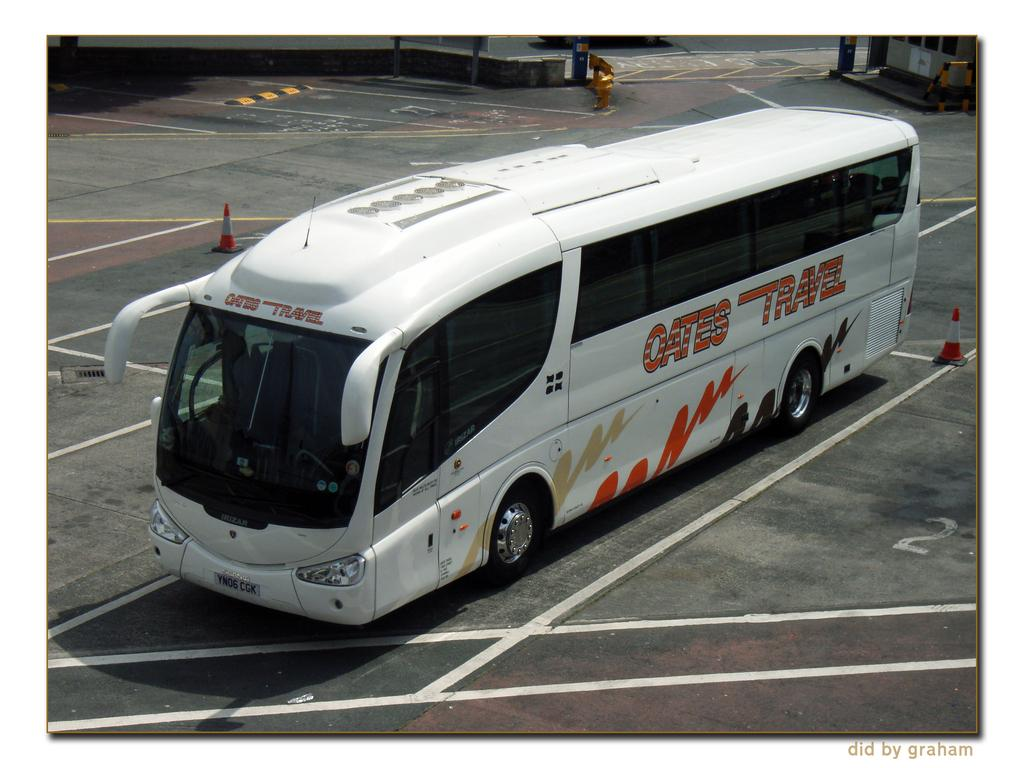What is the main subject of the image? There is a bus in the image. Where is the bus located? The bus is parked in a parking lot. What can be seen in the background of the image? There is a building, two cones, and a metal barricade in the background of the image. What type of beetle can be seen crawling on the bus in the image? There is no beetle present on the bus in the image. How many bits of information can be gathered from the image? The question is not relevant to the image, as it does not involve counting or gathering information from the image. 